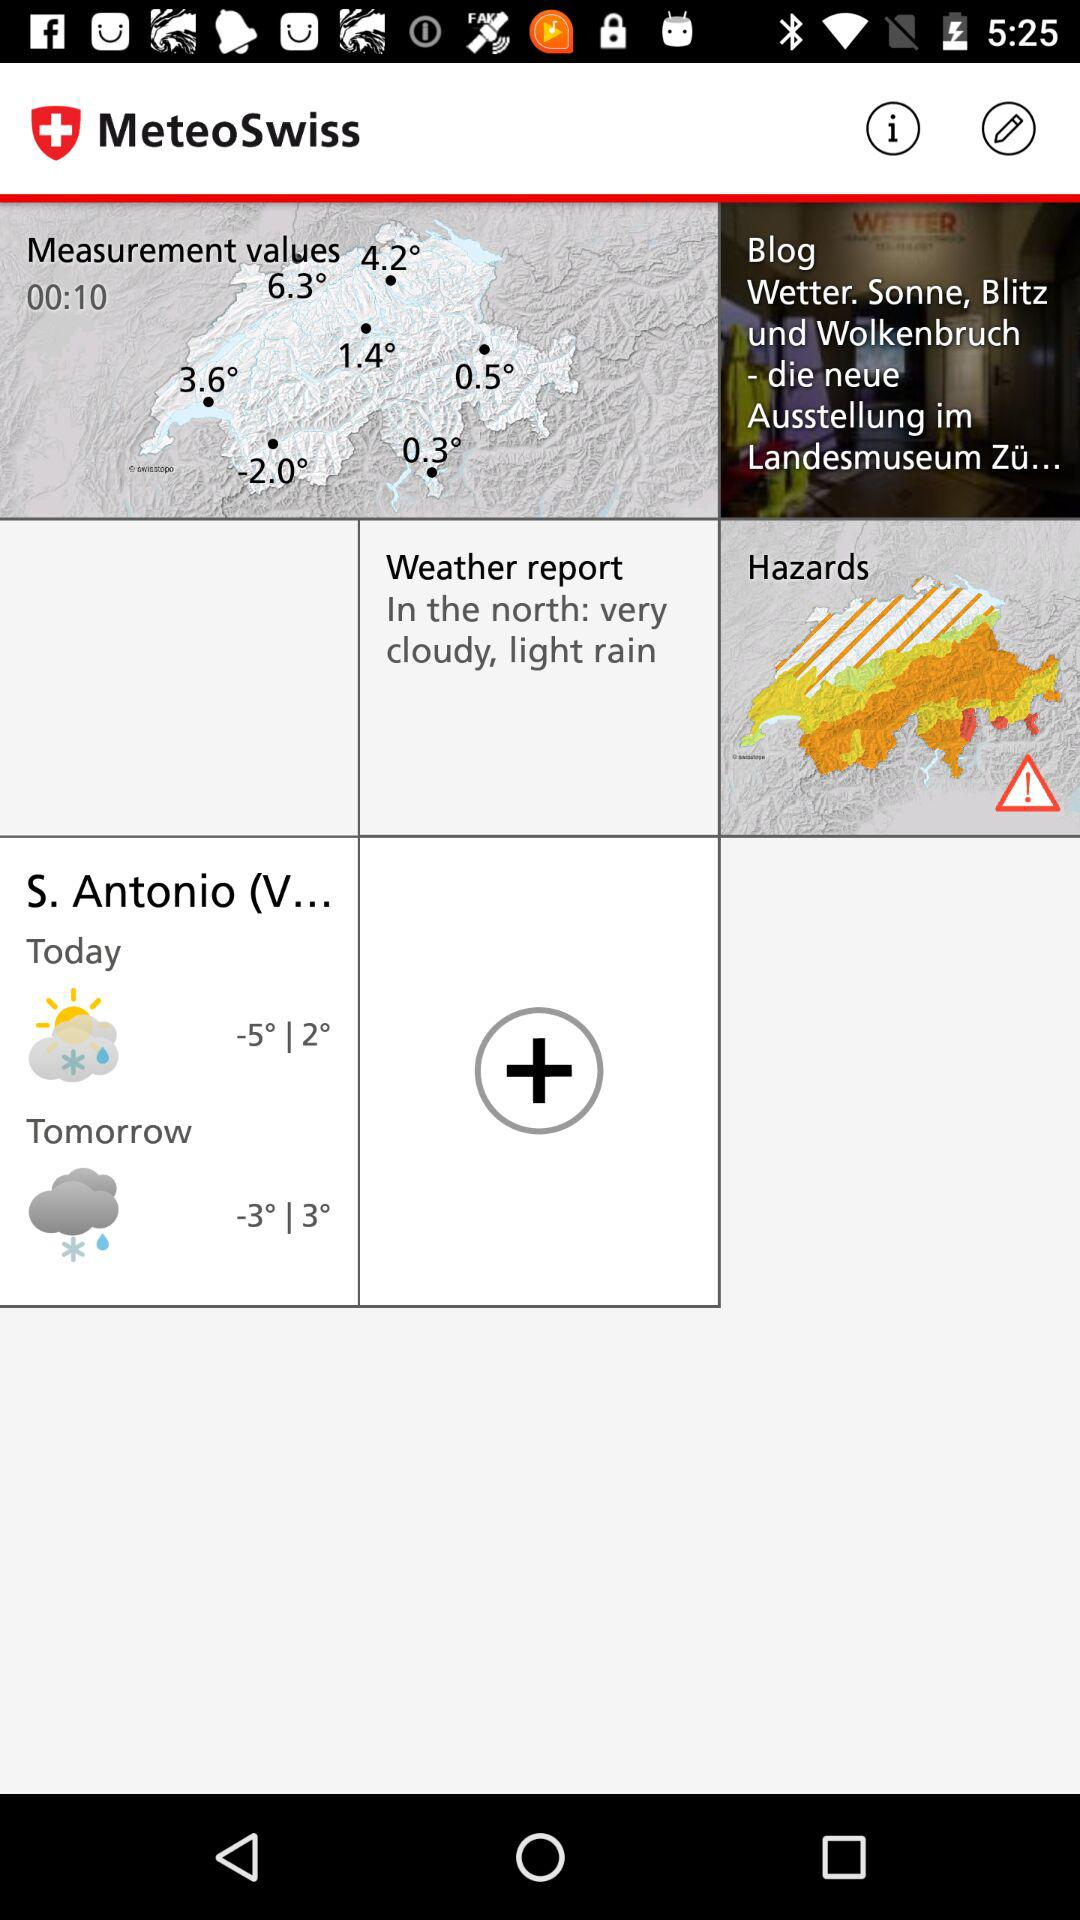What is the weather report? The weather report is "In the north: very cloudy, light rain". 